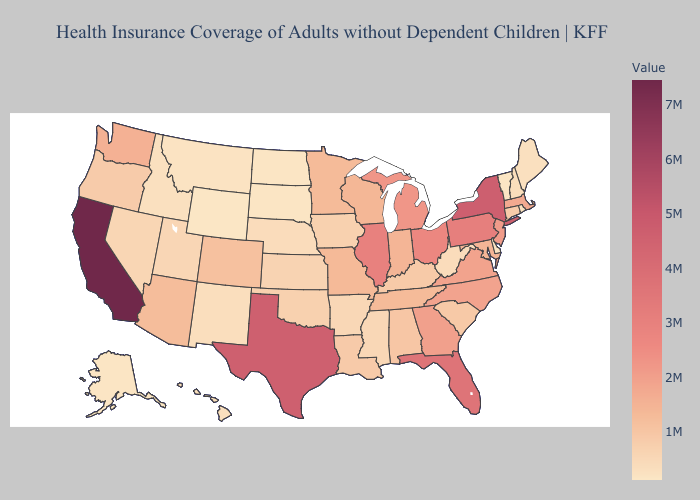Does Wyoming have the lowest value in the USA?
Quick response, please. Yes. Which states have the lowest value in the USA?
Keep it brief. Wyoming. Among the states that border California , which have the lowest value?
Give a very brief answer. Nevada. 